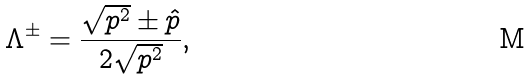<formula> <loc_0><loc_0><loc_500><loc_500>\Lambda ^ { \pm } = \frac { \sqrt { p ^ { 2 } } \pm \hat { p } } { 2 \sqrt { p ^ { 2 } } } ,</formula> 